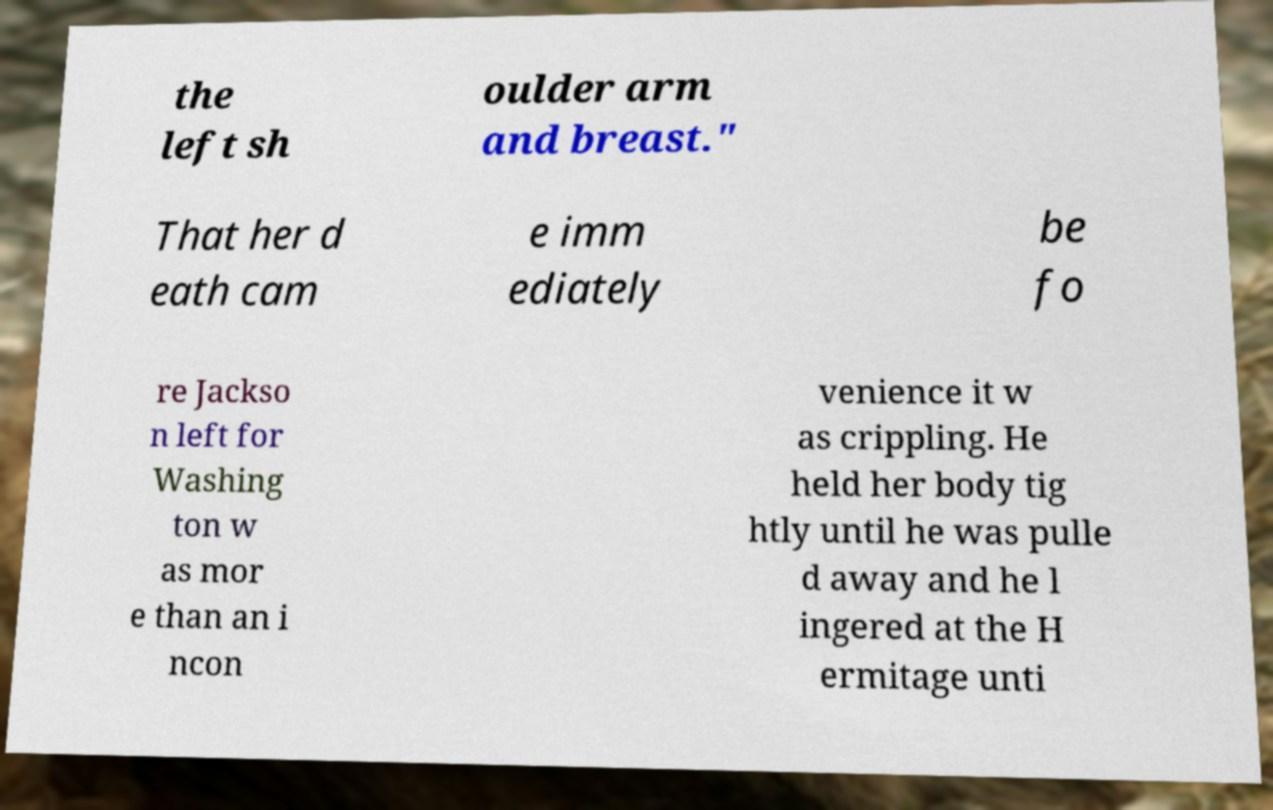Can you accurately transcribe the text from the provided image for me? the left sh oulder arm and breast." That her d eath cam e imm ediately be fo re Jackso n left for Washing ton w as mor e than an i ncon venience it w as crippling. He held her body tig htly until he was pulle d away and he l ingered at the H ermitage unti 